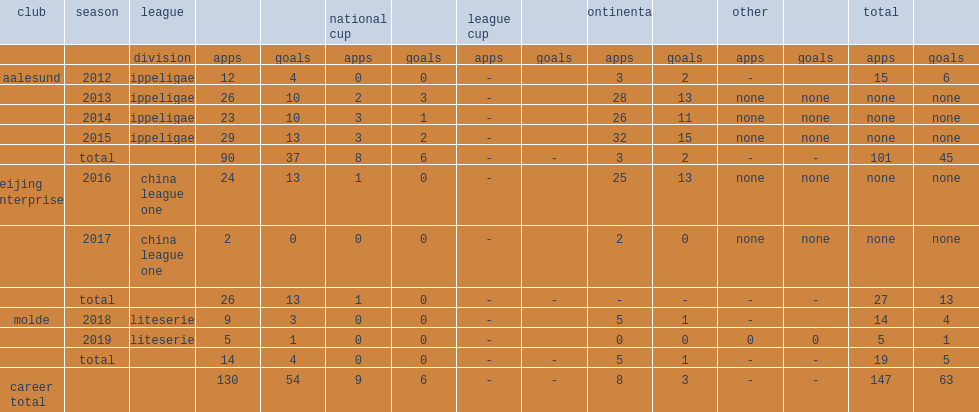In 2016 and 2017, which league did leke james play for beijing enterprises? China league one. 